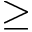Convert formula to latex. <formula><loc_0><loc_0><loc_500><loc_500>\geq</formula> 